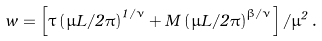<formula> <loc_0><loc_0><loc_500><loc_500>w = \left [ \tau \left ( \mu L / 2 \pi \right ) ^ { 1 / \nu } + M \left ( \mu L / 2 \pi \right ) ^ { \beta / \nu } \right ] / \mu ^ { 2 } \, .</formula> 